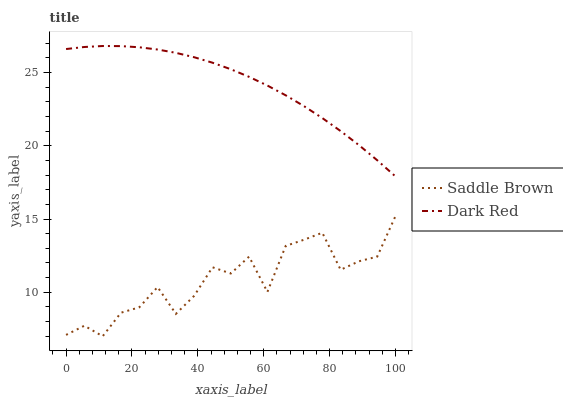Does Saddle Brown have the minimum area under the curve?
Answer yes or no. Yes. Does Dark Red have the maximum area under the curve?
Answer yes or no. Yes. Does Saddle Brown have the maximum area under the curve?
Answer yes or no. No. Is Dark Red the smoothest?
Answer yes or no. Yes. Is Saddle Brown the roughest?
Answer yes or no. Yes. Is Saddle Brown the smoothest?
Answer yes or no. No. Does Saddle Brown have the lowest value?
Answer yes or no. Yes. Does Dark Red have the highest value?
Answer yes or no. Yes. Does Saddle Brown have the highest value?
Answer yes or no. No. Is Saddle Brown less than Dark Red?
Answer yes or no. Yes. Is Dark Red greater than Saddle Brown?
Answer yes or no. Yes. Does Saddle Brown intersect Dark Red?
Answer yes or no. No. 